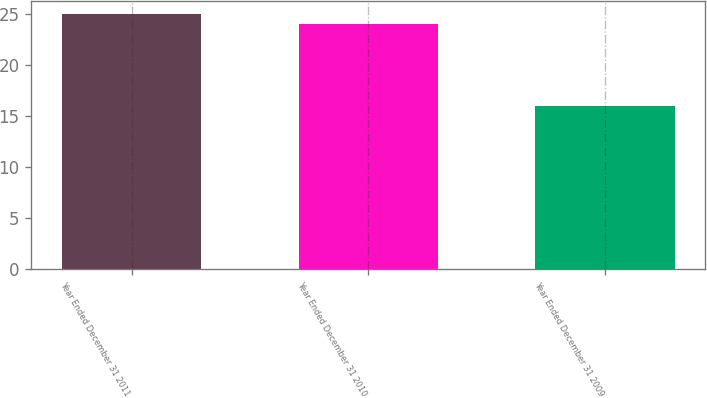Convert chart to OTSL. <chart><loc_0><loc_0><loc_500><loc_500><bar_chart><fcel>Year Ended December 31 2011<fcel>Year Ended December 31 2010<fcel>Year Ended December 31 2009<nl><fcel>25<fcel>24<fcel>16<nl></chart> 